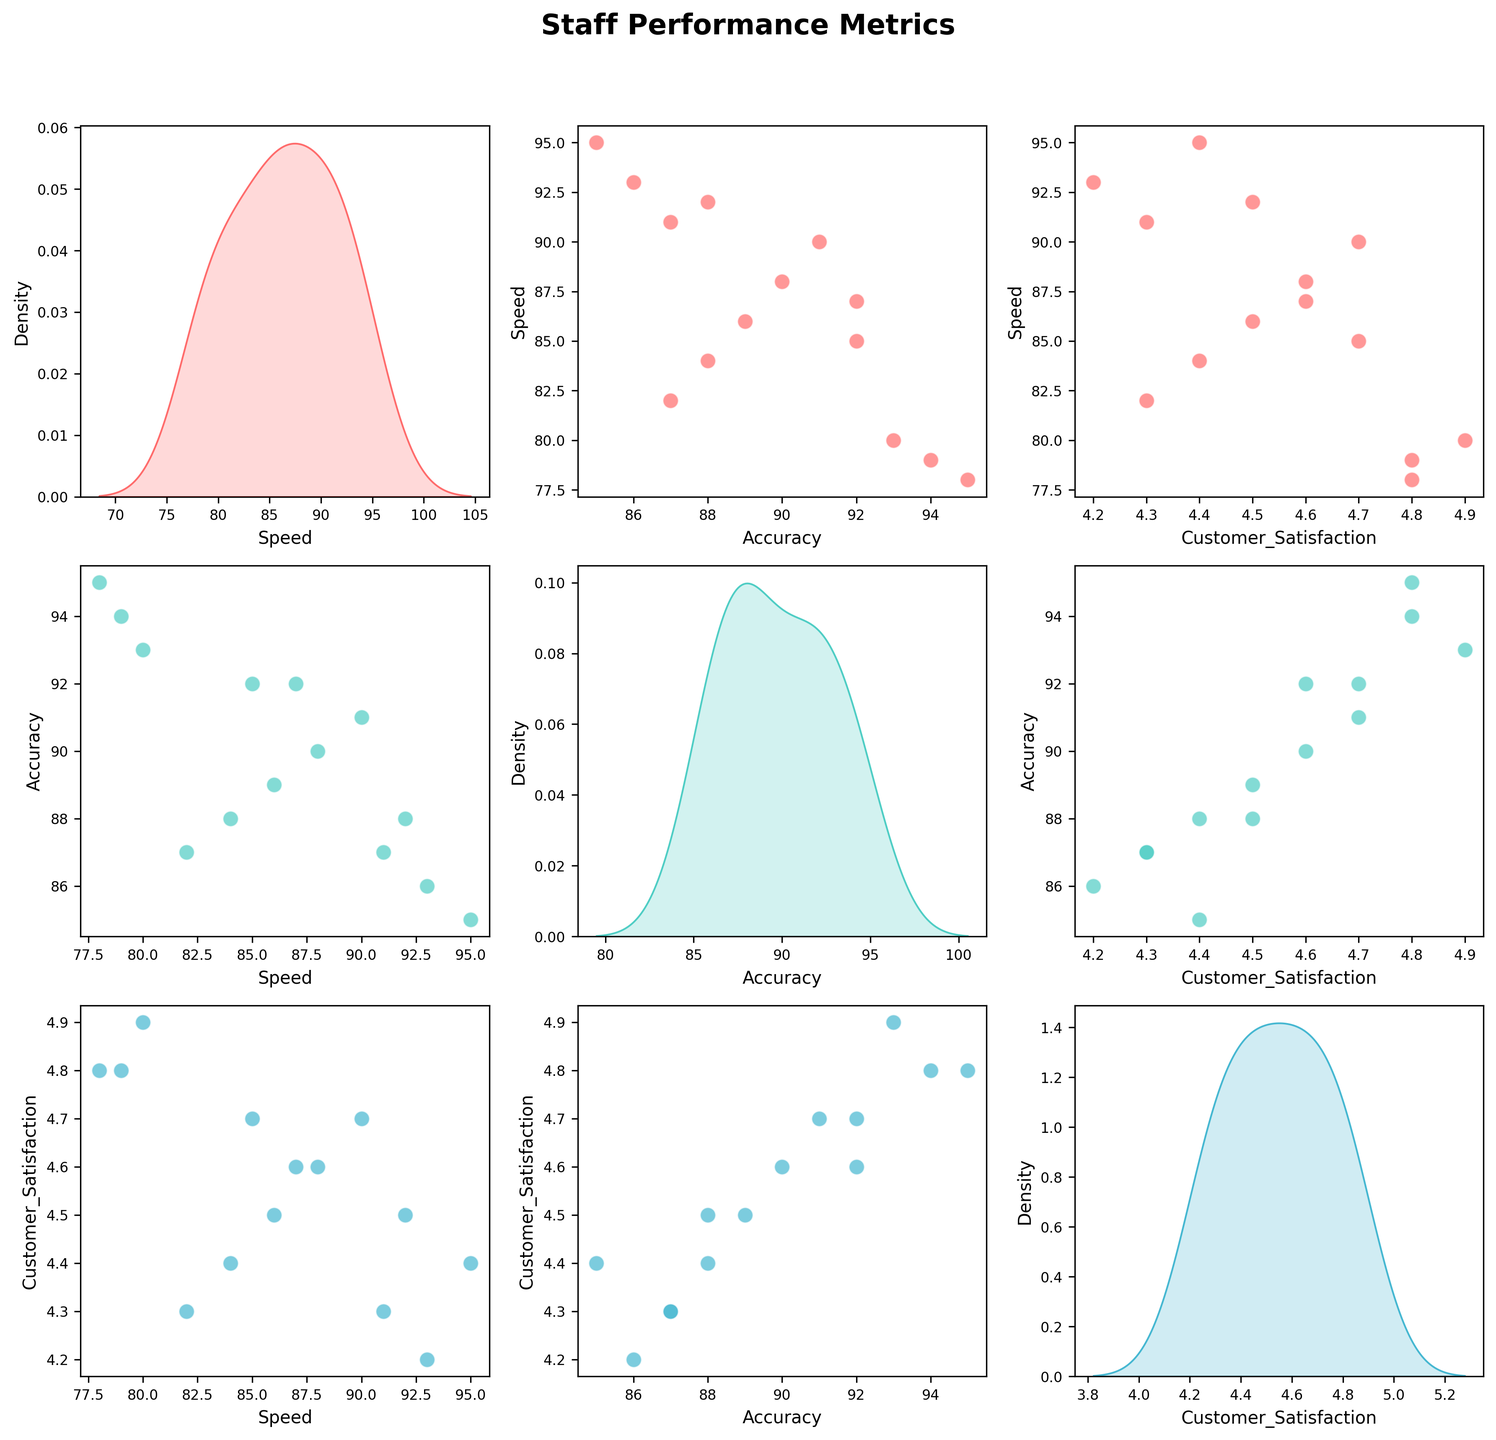What title is given to the scatterplot matrix? The title is located at the top of the scatterplot matrix. It reads "Staff Performance Metrics".
Answer: Staff Performance Metrics What axes labels are used for the scatterplot matrix? Each subplot in the scatterplot matrix has different axes labels based on the metrics. The labels include "Speed", "Accuracy", and "Customer Satisfaction".
Answer: Speed, Accuracy, Customer Satisfaction How many data points are displayed in each scatterplot? Each scatterplot includes one point for each employee. Counting the rows in the dataset, there are 14 employees, hence 14 data points.
Answer: 14 Which pair of metrics shows the strongest positive relationship? Observing the scatterplots, the pair of metrics that shows the strongest positive correlation is the one with the most linear upward trend. Speed and Customer Satisfaction appear to have a strong positive relationship.
Answer: Speed and Customer Satisfaction What's the average value of the 'Speed' metric? To find the average value of 'Speed', sum up all the 'Speed' values and then divide by the number of employees: (85 + 92 + 78 + 88 + 82 + 95 + 80 + 90 + 86 + 93 + 79 + 87 + 84 + 91) / 14. Calculation: 1210 / 14 ≈ 86.43
Answer: 86.43 Based on the scatterplot matrix, which data points indicate employees with both high 'Accuracy' and high 'Customer Satisfaction' scores? Look for scatterplots where both 'Accuracy' and 'Customer Satisfaction' are plotted, and identify data points in the upper right quadrant. Employees John, Carlos, Daniel, Lucas, and Olivia satisfy these conditions.
Answer: John, Carlos, Daniel, Lucas, and Olivia Is there a notable outlier in terms of 'Speed' in the dataset? In a scatterplot matrix, an outlier would be a point far from the cluster of other points. Observing the 'Speed' metric, Mia has a notably higher 'Speed' (95) compared to others.
Answer: Mia What's the median value of 'Accuracy'? To find the median, order the 'Accuracy' values and find the middle one. Sorted 'Accuracy' values: 85, 86, 87, 87, 88, 88, 89, 90, 91, 92, 92, 93, 94, 95. The median is the average of the 7th and 8th values (89 and 90), which gives (89 + 90) / 2 = 89.5.
Answer: 89.5 